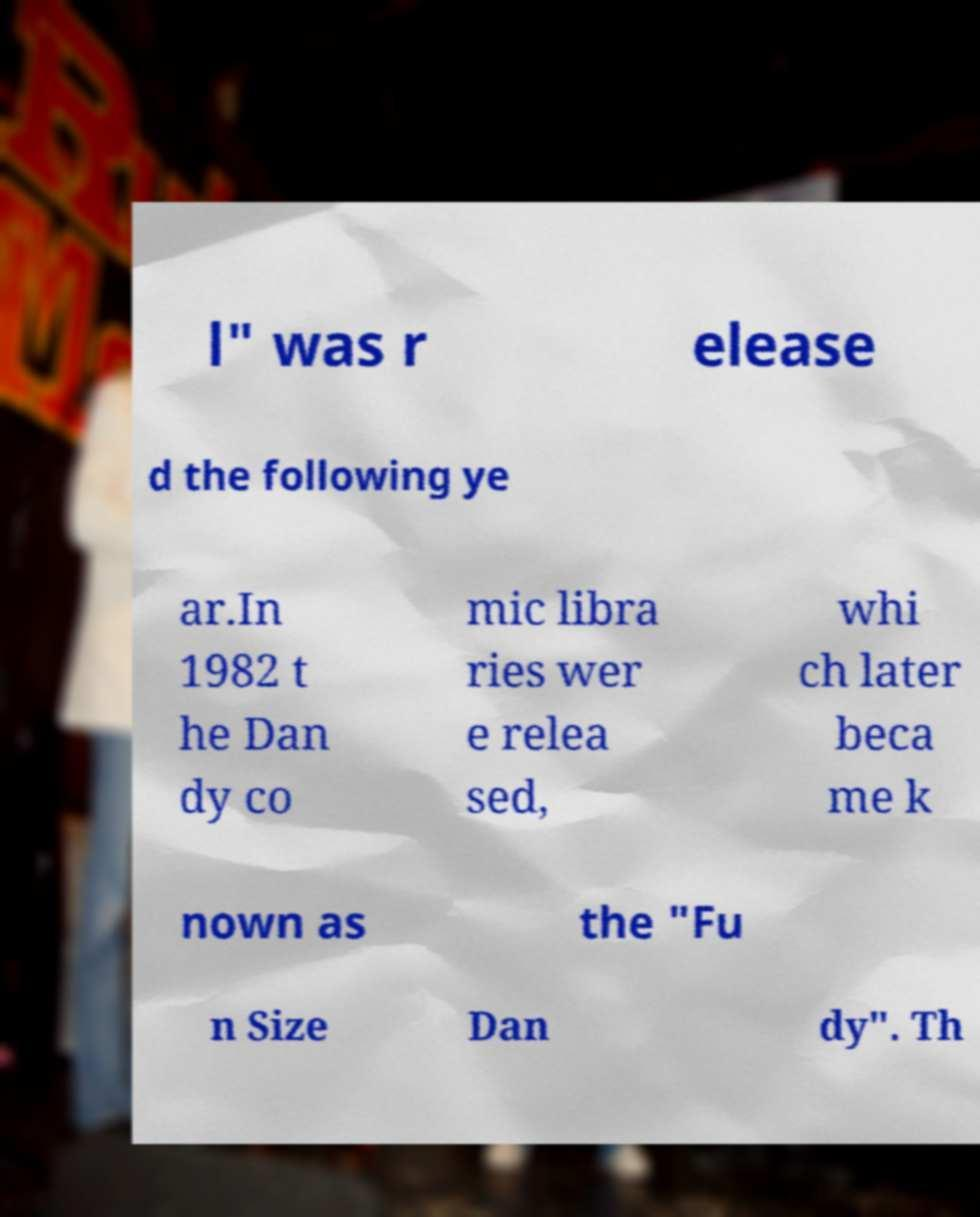There's text embedded in this image that I need extracted. Can you transcribe it verbatim? l" was r elease d the following ye ar.In 1982 t he Dan dy co mic libra ries wer e relea sed, whi ch later beca me k nown as the "Fu n Size Dan dy". Th 